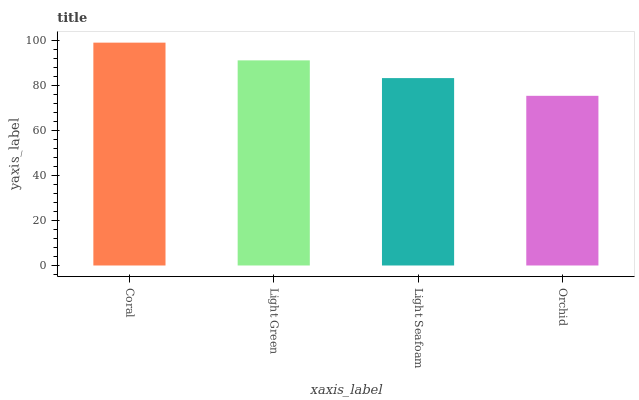Is Orchid the minimum?
Answer yes or no. Yes. Is Coral the maximum?
Answer yes or no. Yes. Is Light Green the minimum?
Answer yes or no. No. Is Light Green the maximum?
Answer yes or no. No. Is Coral greater than Light Green?
Answer yes or no. Yes. Is Light Green less than Coral?
Answer yes or no. Yes. Is Light Green greater than Coral?
Answer yes or no. No. Is Coral less than Light Green?
Answer yes or no. No. Is Light Green the high median?
Answer yes or no. Yes. Is Light Seafoam the low median?
Answer yes or no. Yes. Is Light Seafoam the high median?
Answer yes or no. No. Is Orchid the low median?
Answer yes or no. No. 